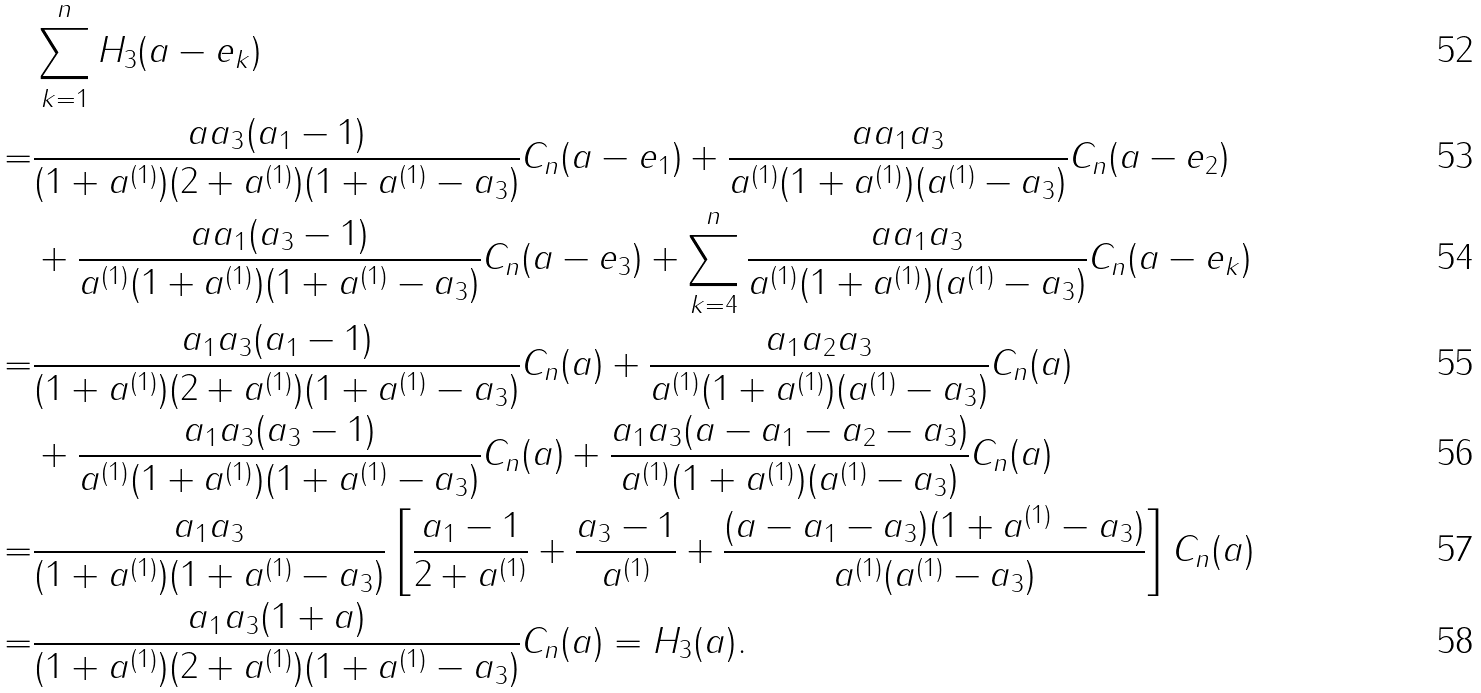<formula> <loc_0><loc_0><loc_500><loc_500>& \sum _ { k = 1 } ^ { n } H _ { 3 } ( a - e _ { k } ) \\ = & \frac { a a _ { 3 } ( a _ { 1 } - 1 ) } { ( 1 + a ^ { ( 1 ) } ) ( 2 + a ^ { ( 1 ) } ) ( 1 + a ^ { ( 1 ) } - a _ { 3 } ) } C _ { n } ( a - e _ { 1 } ) + \frac { a a _ { 1 } a _ { 3 } } { a ^ { ( 1 ) } ( 1 + a ^ { ( 1 ) } ) ( a ^ { ( 1 ) } - a _ { 3 } ) } C _ { n } ( a - e _ { 2 } ) \\ & + \frac { a a _ { 1 } ( a _ { 3 } - 1 ) } { a ^ { ( 1 ) } ( 1 + a ^ { ( 1 ) } ) ( 1 + a ^ { ( 1 ) } - a _ { 3 } ) } C _ { n } ( a - e _ { 3 } ) + \sum _ { k = 4 } ^ { n } \frac { a a _ { 1 } a _ { 3 } } { a ^ { ( 1 ) } ( 1 + a ^ { ( 1 ) } ) ( a ^ { ( 1 ) } - a _ { 3 } ) } C _ { n } ( a - e _ { k } ) \\ = & \frac { a _ { 1 } a _ { 3 } ( a _ { 1 } - 1 ) } { ( 1 + a ^ { ( 1 ) } ) ( 2 + a ^ { ( 1 ) } ) ( 1 + a ^ { ( 1 ) } - a _ { 3 } ) } C _ { n } ( a ) + \frac { a _ { 1 } a _ { 2 } a _ { 3 } } { a ^ { ( 1 ) } ( 1 + a ^ { ( 1 ) } ) ( a ^ { ( 1 ) } - a _ { 3 } ) } C _ { n } ( a ) \\ & + \frac { a _ { 1 } a _ { 3 } ( a _ { 3 } - 1 ) } { a ^ { ( 1 ) } ( 1 + a ^ { ( 1 ) } ) ( 1 + a ^ { ( 1 ) } - a _ { 3 } ) } C _ { n } ( a ) + \frac { a _ { 1 } a _ { 3 } ( a - a _ { 1 } - a _ { 2 } - a _ { 3 } ) } { a ^ { ( 1 ) } ( 1 + a ^ { ( 1 ) } ) ( a ^ { ( 1 ) } - a _ { 3 } ) } C _ { n } ( a ) \\ = & \frac { a _ { 1 } a _ { 3 } } { ( 1 + a ^ { ( 1 ) } ) ( 1 + a ^ { ( 1 ) } - a _ { 3 } ) } \left [ \frac { a _ { 1 } - 1 } { 2 + a ^ { ( 1 ) } } + \frac { a _ { 3 } - 1 } { a ^ { ( 1 ) } } + \frac { ( a - a _ { 1 } - a _ { 3 } ) ( 1 + a ^ { ( 1 ) } - a _ { 3 } ) } { a ^ { ( 1 ) } ( a ^ { ( 1 ) } - a _ { 3 } ) } \right ] C _ { n } ( a ) \\ = & \frac { a _ { 1 } a _ { 3 } ( 1 + a ) } { ( 1 + a ^ { ( 1 ) } ) ( 2 + a ^ { ( 1 ) } ) ( 1 + a ^ { ( 1 ) } - a _ { 3 } ) } C _ { n } ( a ) = H _ { 3 } ( a ) .</formula> 